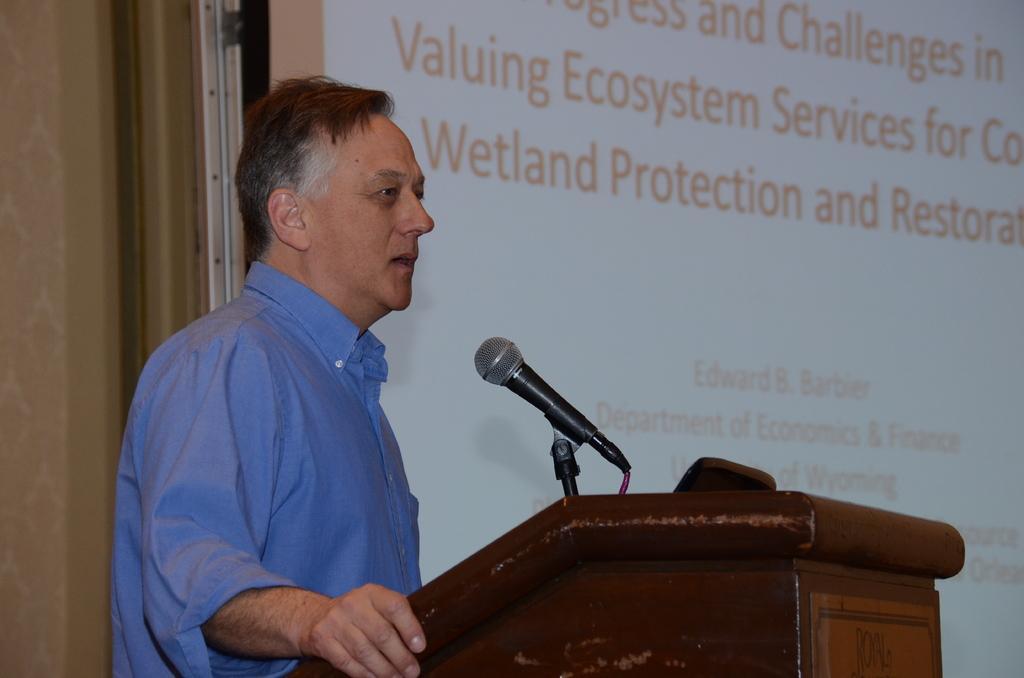Describe this image in one or two sentences. In this image we can see a man standing at the podium to which a mic is attached. In the background there is a display screen with some text on it. 